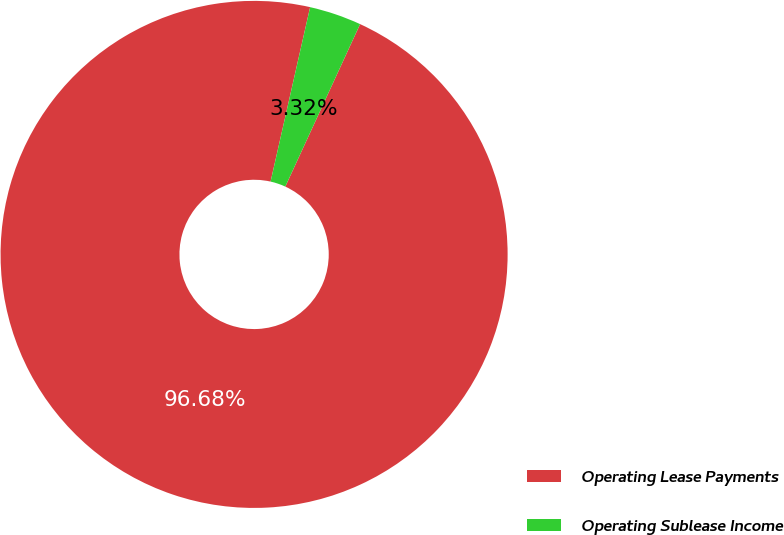Convert chart to OTSL. <chart><loc_0><loc_0><loc_500><loc_500><pie_chart><fcel>Operating Lease Payments<fcel>Operating Sublease Income<nl><fcel>96.68%<fcel>3.32%<nl></chart> 